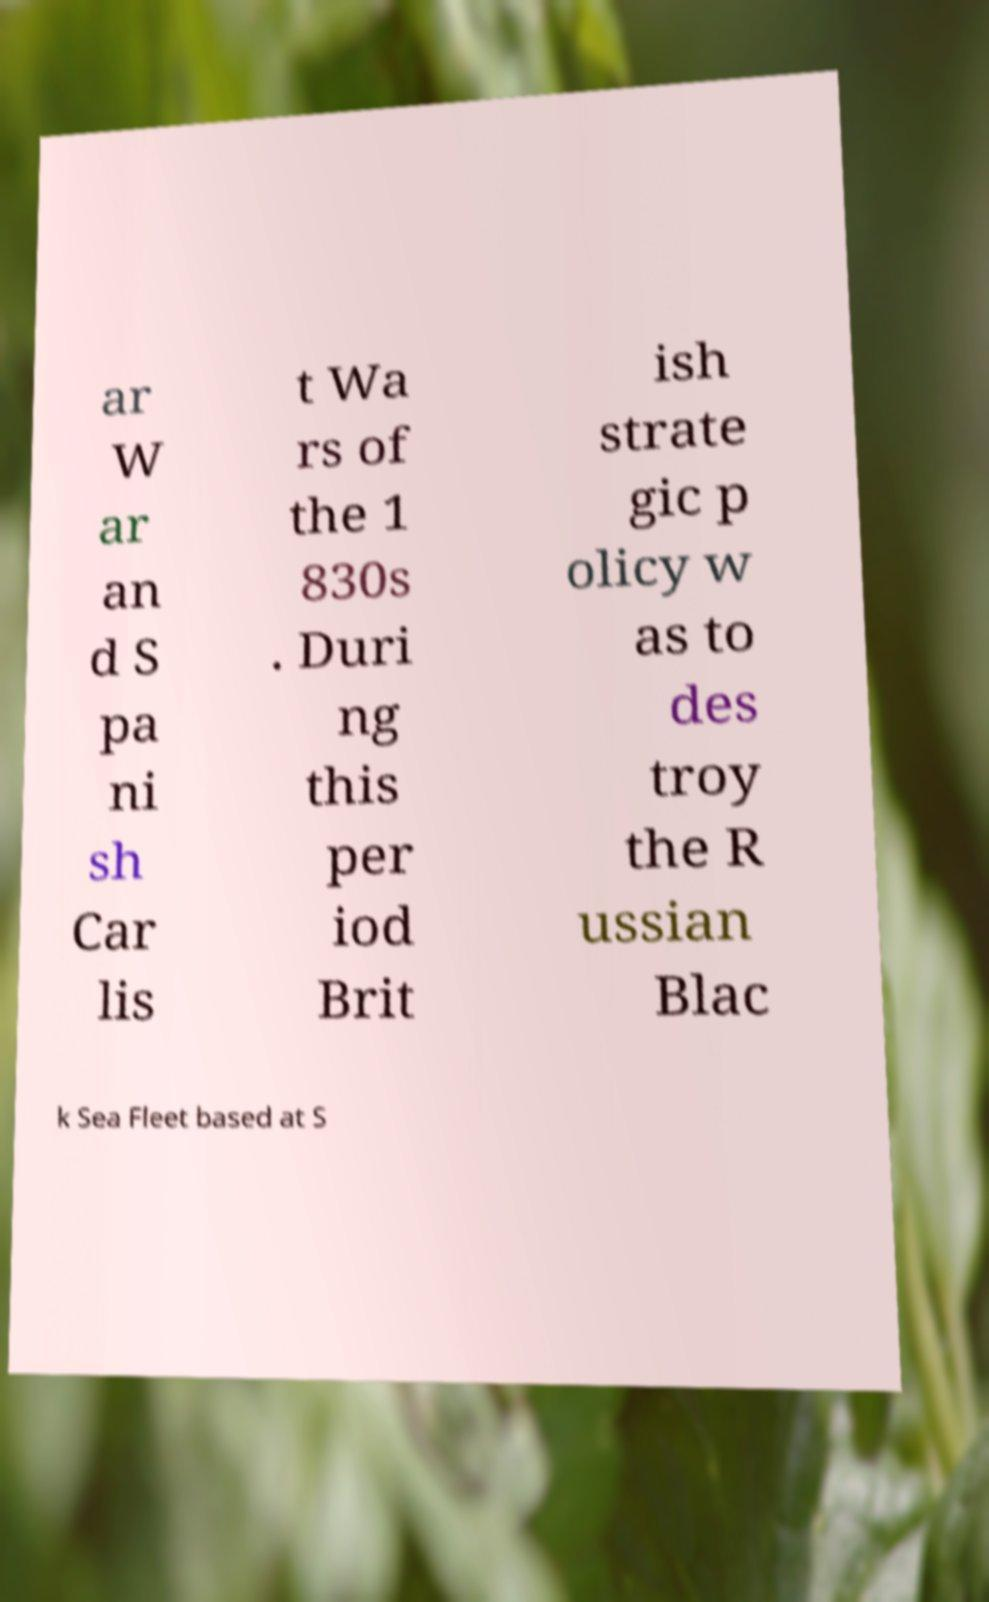Please read and relay the text visible in this image. What does it say? ar W ar an d S pa ni sh Car lis t Wa rs of the 1 830s . Duri ng this per iod Brit ish strate gic p olicy w as to des troy the R ussian Blac k Sea Fleet based at S 